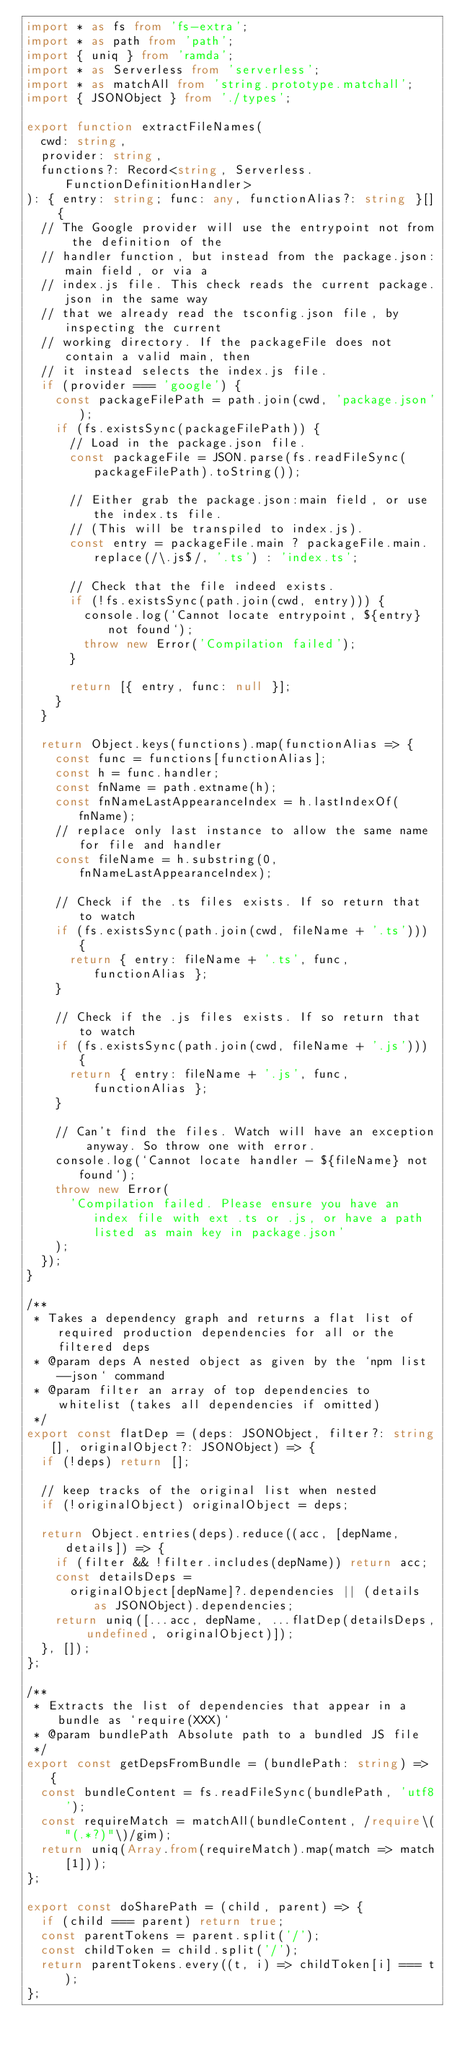Convert code to text. <code><loc_0><loc_0><loc_500><loc_500><_TypeScript_>import * as fs from 'fs-extra';
import * as path from 'path';
import { uniq } from 'ramda';
import * as Serverless from 'serverless';
import * as matchAll from 'string.prototype.matchall';
import { JSONObject } from './types';

export function extractFileNames(
  cwd: string,
  provider: string,
  functions?: Record<string, Serverless.FunctionDefinitionHandler>
): { entry: string; func: any, functionAlias?: string }[] {
  // The Google provider will use the entrypoint not from the definition of the
  // handler function, but instead from the package.json:main field, or via a
  // index.js file. This check reads the current package.json in the same way
  // that we already read the tsconfig.json file, by inspecting the current
  // working directory. If the packageFile does not contain a valid main, then
  // it instead selects the index.js file.
  if (provider === 'google') {
    const packageFilePath = path.join(cwd, 'package.json');
    if (fs.existsSync(packageFilePath)) {
      // Load in the package.json file.
      const packageFile = JSON.parse(fs.readFileSync(packageFilePath).toString());

      // Either grab the package.json:main field, or use the index.ts file.
      // (This will be transpiled to index.js).
      const entry = packageFile.main ? packageFile.main.replace(/\.js$/, '.ts') : 'index.ts';

      // Check that the file indeed exists.
      if (!fs.existsSync(path.join(cwd, entry))) {
        console.log(`Cannot locate entrypoint, ${entry} not found`);
        throw new Error('Compilation failed');
      }

      return [{ entry, func: null }];
    }
  }

  return Object.keys(functions).map(functionAlias => {
    const func = functions[functionAlias];
    const h = func.handler;
    const fnName = path.extname(h);
    const fnNameLastAppearanceIndex = h.lastIndexOf(fnName);
    // replace only last instance to allow the same name for file and handler
    const fileName = h.substring(0, fnNameLastAppearanceIndex);

    // Check if the .ts files exists. If so return that to watch
    if (fs.existsSync(path.join(cwd, fileName + '.ts'))) {
      return { entry: fileName + '.ts', func, functionAlias };
    }

    // Check if the .js files exists. If so return that to watch
    if (fs.existsSync(path.join(cwd, fileName + '.js'))) {
      return { entry: fileName + '.js', func, functionAlias };
    }

    // Can't find the files. Watch will have an exception anyway. So throw one with error.
    console.log(`Cannot locate handler - ${fileName} not found`);
    throw new Error(
      'Compilation failed. Please ensure you have an index file with ext .ts or .js, or have a path listed as main key in package.json'
    );
  });
}

/**
 * Takes a dependency graph and returns a flat list of required production dependencies for all or the filtered deps
 * @param deps A nested object as given by the `npm list --json` command
 * @param filter an array of top dependencies to whitelist (takes all dependencies if omitted)
 */
export const flatDep = (deps: JSONObject, filter?: string[], originalObject?: JSONObject) => {
  if (!deps) return [];

  // keep tracks of the original list when nested
  if (!originalObject) originalObject = deps;

  return Object.entries(deps).reduce((acc, [depName, details]) => {
    if (filter && !filter.includes(depName)) return acc;
    const detailsDeps =
      originalObject[depName]?.dependencies || (details as JSONObject).dependencies;
    return uniq([...acc, depName, ...flatDep(detailsDeps, undefined, originalObject)]);
  }, []);
};

/**
 * Extracts the list of dependencies that appear in a bundle as `require(XXX)`
 * @param bundlePath Absolute path to a bundled JS file
 */
export const getDepsFromBundle = (bundlePath: string) => {
  const bundleContent = fs.readFileSync(bundlePath, 'utf8');
  const requireMatch = matchAll(bundleContent, /require\("(.*?)"\)/gim);
  return uniq(Array.from(requireMatch).map(match => match[1]));
};

export const doSharePath = (child, parent) => {
  if (child === parent) return true;
  const parentTokens = parent.split('/');
  const childToken = child.split('/');
  return parentTokens.every((t, i) => childToken[i] === t);
};
</code> 